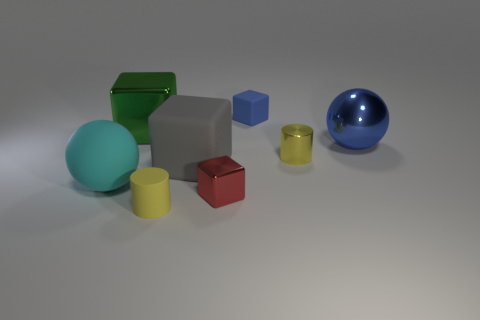Subtract all large gray blocks. How many blocks are left? 3 Add 1 big metallic things. How many objects exist? 9 Subtract 2 cubes. How many cubes are left? 2 Subtract all cylinders. How many objects are left? 6 Subtract all purple cubes. Subtract all gray cylinders. How many cubes are left? 4 Subtract all red blocks. Subtract all small blue blocks. How many objects are left? 6 Add 7 green metallic objects. How many green metallic objects are left? 8 Add 8 tiny blue things. How many tiny blue things exist? 9 Subtract 0 gray spheres. How many objects are left? 8 